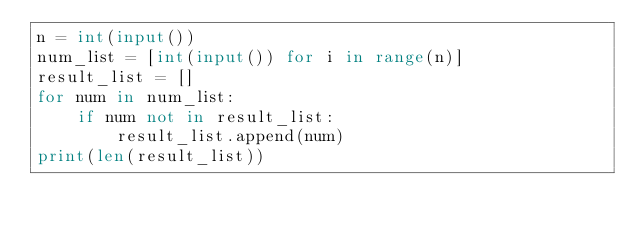Convert code to text. <code><loc_0><loc_0><loc_500><loc_500><_Python_>n = int(input())
num_list = [int(input()) for i in range(n)]
result_list = []
for num in num_list:
    if num not in result_list:
        result_list.append(num)
print(len(result_list))</code> 